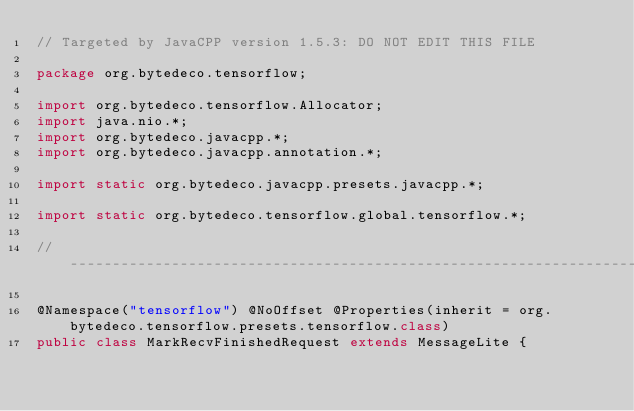Convert code to text. <code><loc_0><loc_0><loc_500><loc_500><_Java_>// Targeted by JavaCPP version 1.5.3: DO NOT EDIT THIS FILE

package org.bytedeco.tensorflow;

import org.bytedeco.tensorflow.Allocator;
import java.nio.*;
import org.bytedeco.javacpp.*;
import org.bytedeco.javacpp.annotation.*;

import static org.bytedeco.javacpp.presets.javacpp.*;

import static org.bytedeco.tensorflow.global.tensorflow.*;

// -------------------------------------------------------------------

@Namespace("tensorflow") @NoOffset @Properties(inherit = org.bytedeco.tensorflow.presets.tensorflow.class)
public class MarkRecvFinishedRequest extends MessageLite {</code> 